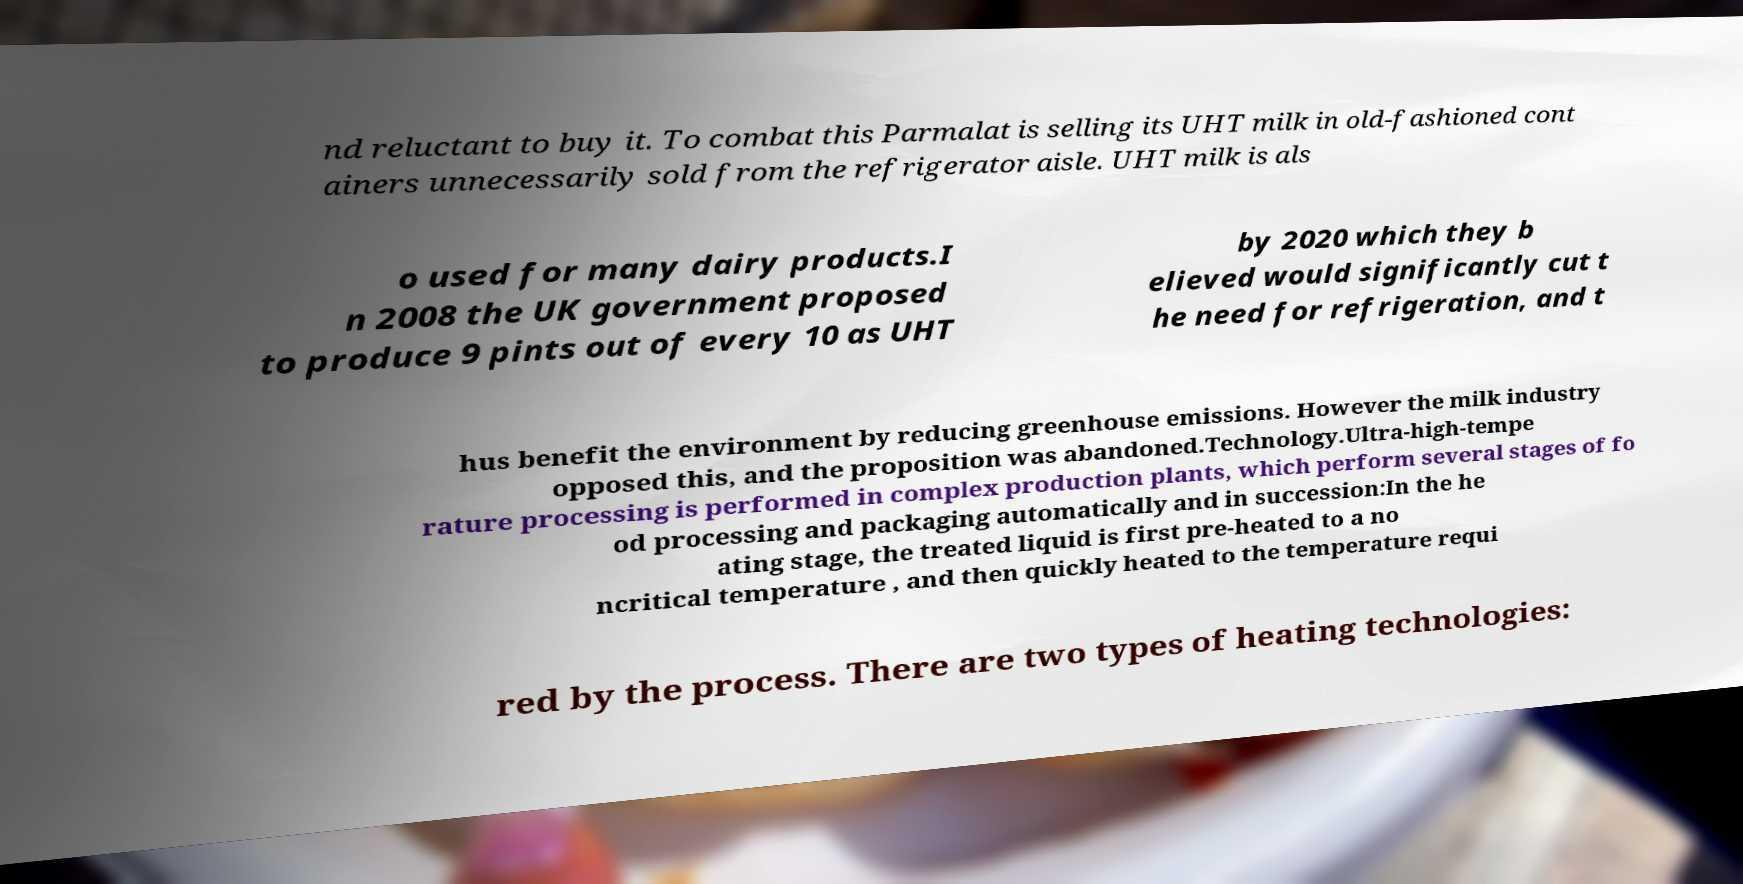Please read and relay the text visible in this image. What does it say? nd reluctant to buy it. To combat this Parmalat is selling its UHT milk in old-fashioned cont ainers unnecessarily sold from the refrigerator aisle. UHT milk is als o used for many dairy products.I n 2008 the UK government proposed to produce 9 pints out of every 10 as UHT by 2020 which they b elieved would significantly cut t he need for refrigeration, and t hus benefit the environment by reducing greenhouse emissions. However the milk industry opposed this, and the proposition was abandoned.Technology.Ultra-high-tempe rature processing is performed in complex production plants, which perform several stages of fo od processing and packaging automatically and in succession:In the he ating stage, the treated liquid is first pre-heated to a no ncritical temperature , and then quickly heated to the temperature requi red by the process. There are two types of heating technologies: 